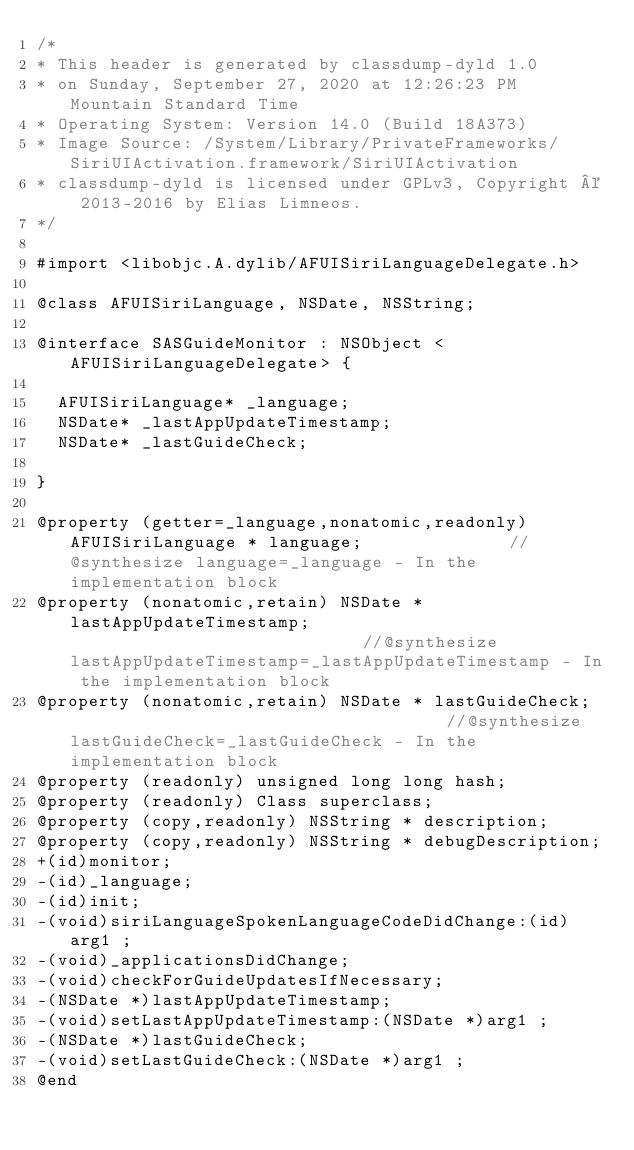<code> <loc_0><loc_0><loc_500><loc_500><_C_>/*
* This header is generated by classdump-dyld 1.0
* on Sunday, September 27, 2020 at 12:26:23 PM Mountain Standard Time
* Operating System: Version 14.0 (Build 18A373)
* Image Source: /System/Library/PrivateFrameworks/SiriUIActivation.framework/SiriUIActivation
* classdump-dyld is licensed under GPLv3, Copyright © 2013-2016 by Elias Limneos.
*/

#import <libobjc.A.dylib/AFUISiriLanguageDelegate.h>

@class AFUISiriLanguage, NSDate, NSString;

@interface SASGuideMonitor : NSObject <AFUISiriLanguageDelegate> {

	AFUISiriLanguage* _language;
	NSDate* _lastAppUpdateTimestamp;
	NSDate* _lastGuideCheck;

}

@property (getter=_language,nonatomic,readonly) AFUISiriLanguage * language;              //@synthesize language=_language - In the implementation block
@property (nonatomic,retain) NSDate * lastAppUpdateTimestamp;                             //@synthesize lastAppUpdateTimestamp=_lastAppUpdateTimestamp - In the implementation block
@property (nonatomic,retain) NSDate * lastGuideCheck;                                     //@synthesize lastGuideCheck=_lastGuideCheck - In the implementation block
@property (readonly) unsigned long long hash; 
@property (readonly) Class superclass; 
@property (copy,readonly) NSString * description; 
@property (copy,readonly) NSString * debugDescription; 
+(id)monitor;
-(id)_language;
-(id)init;
-(void)siriLanguageSpokenLanguageCodeDidChange:(id)arg1 ;
-(void)_applicationsDidChange;
-(void)checkForGuideUpdatesIfNecessary;
-(NSDate *)lastAppUpdateTimestamp;
-(void)setLastAppUpdateTimestamp:(NSDate *)arg1 ;
-(NSDate *)lastGuideCheck;
-(void)setLastGuideCheck:(NSDate *)arg1 ;
@end

</code> 